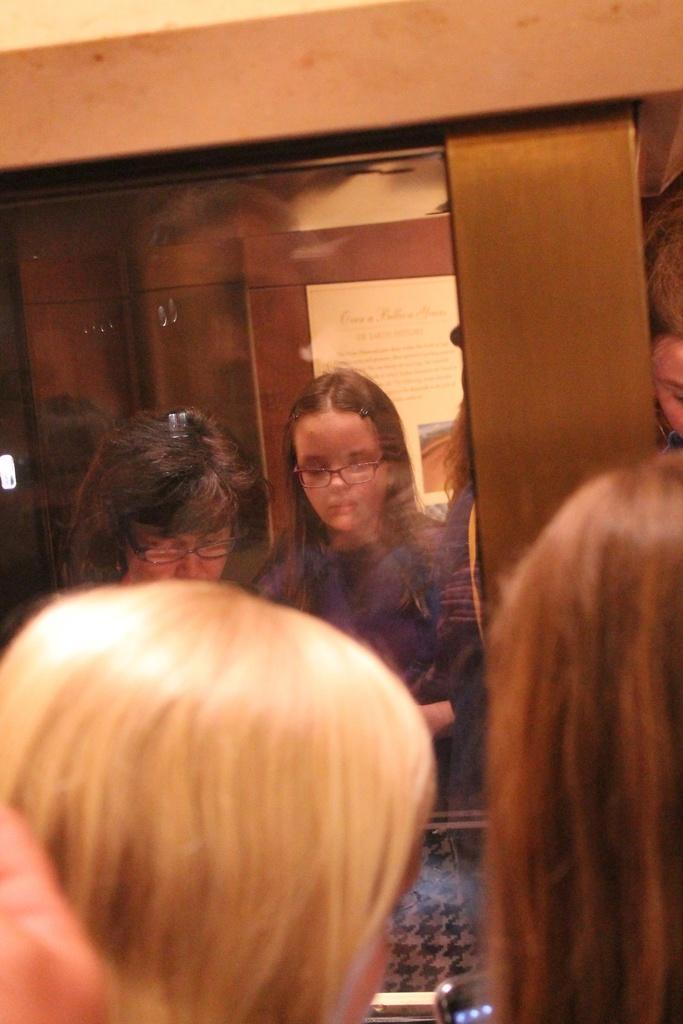How would you summarize this image in a sentence or two? In this picture we can see some people standing, mobile, mirror, cupboards and a poster. 